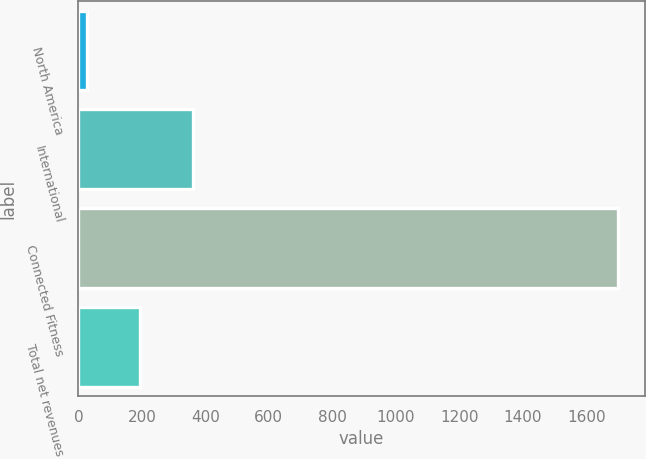Convert chart to OTSL. <chart><loc_0><loc_0><loc_500><loc_500><bar_chart><fcel>North America<fcel>International<fcel>Connected Fitness<fcel>Total net revenues<nl><fcel>27.5<fcel>362.02<fcel>1700.1<fcel>194.76<nl></chart> 